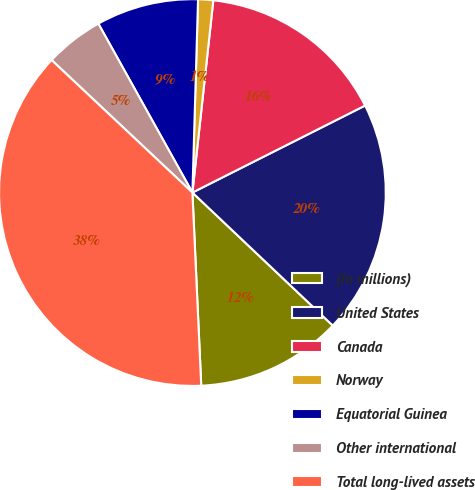Convert chart to OTSL. <chart><loc_0><loc_0><loc_500><loc_500><pie_chart><fcel>(In millions)<fcel>United States<fcel>Canada<fcel>Norway<fcel>Equatorial Guinea<fcel>Other international<fcel>Total long-lived assets<nl><fcel>12.2%<fcel>19.5%<fcel>15.85%<fcel>1.26%<fcel>8.55%<fcel>4.9%<fcel>37.74%<nl></chart> 